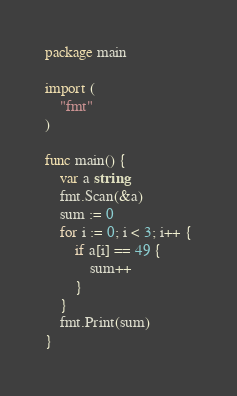Convert code to text. <code><loc_0><loc_0><loc_500><loc_500><_Go_>package main

import (
	"fmt"
)

func main() {
	var a string
	fmt.Scan(&a)
	sum := 0
	for i := 0; i < 3; i++ {
		if a[i] == 49 {
			sum++
		}
	}
	fmt.Print(sum)
}
</code> 